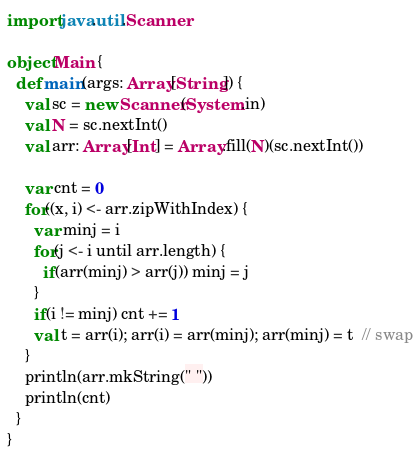<code> <loc_0><loc_0><loc_500><loc_500><_Scala_>import java.util.Scanner

object Main {
  def main(args: Array[String]) {
    val sc = new Scanner(System.in)
    val N = sc.nextInt()
    val arr: Array[Int] = Array.fill(N)(sc.nextInt())

    var cnt = 0
    for((x, i) <- arr.zipWithIndex) {
      var minj = i
      for(j <- i until arr.length) {
        if(arr(minj) > arr(j)) minj = j
      }
      if(i != minj) cnt += 1
      val t = arr(i); arr(i) = arr(minj); arr(minj) = t  // swap
    }
    println(arr.mkString(" "))
    println(cnt)
  }
}</code> 